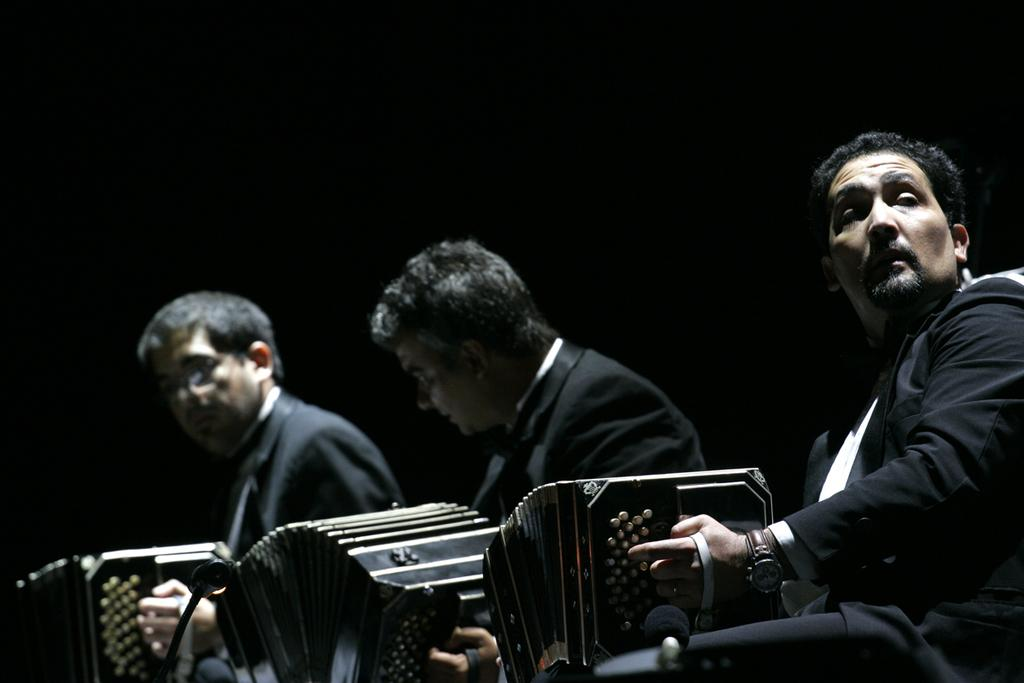How many people are in the image? There are three men in the image. What are the men holding in the image? Each man is holding an accordion. What can be observed about the background of the image? The background of the image is dark. What type of jeans are the men wearing in the image? There is no information about the men's clothing in the image, so it cannot be determined if they are wearing jeans or any other type of clothing. 